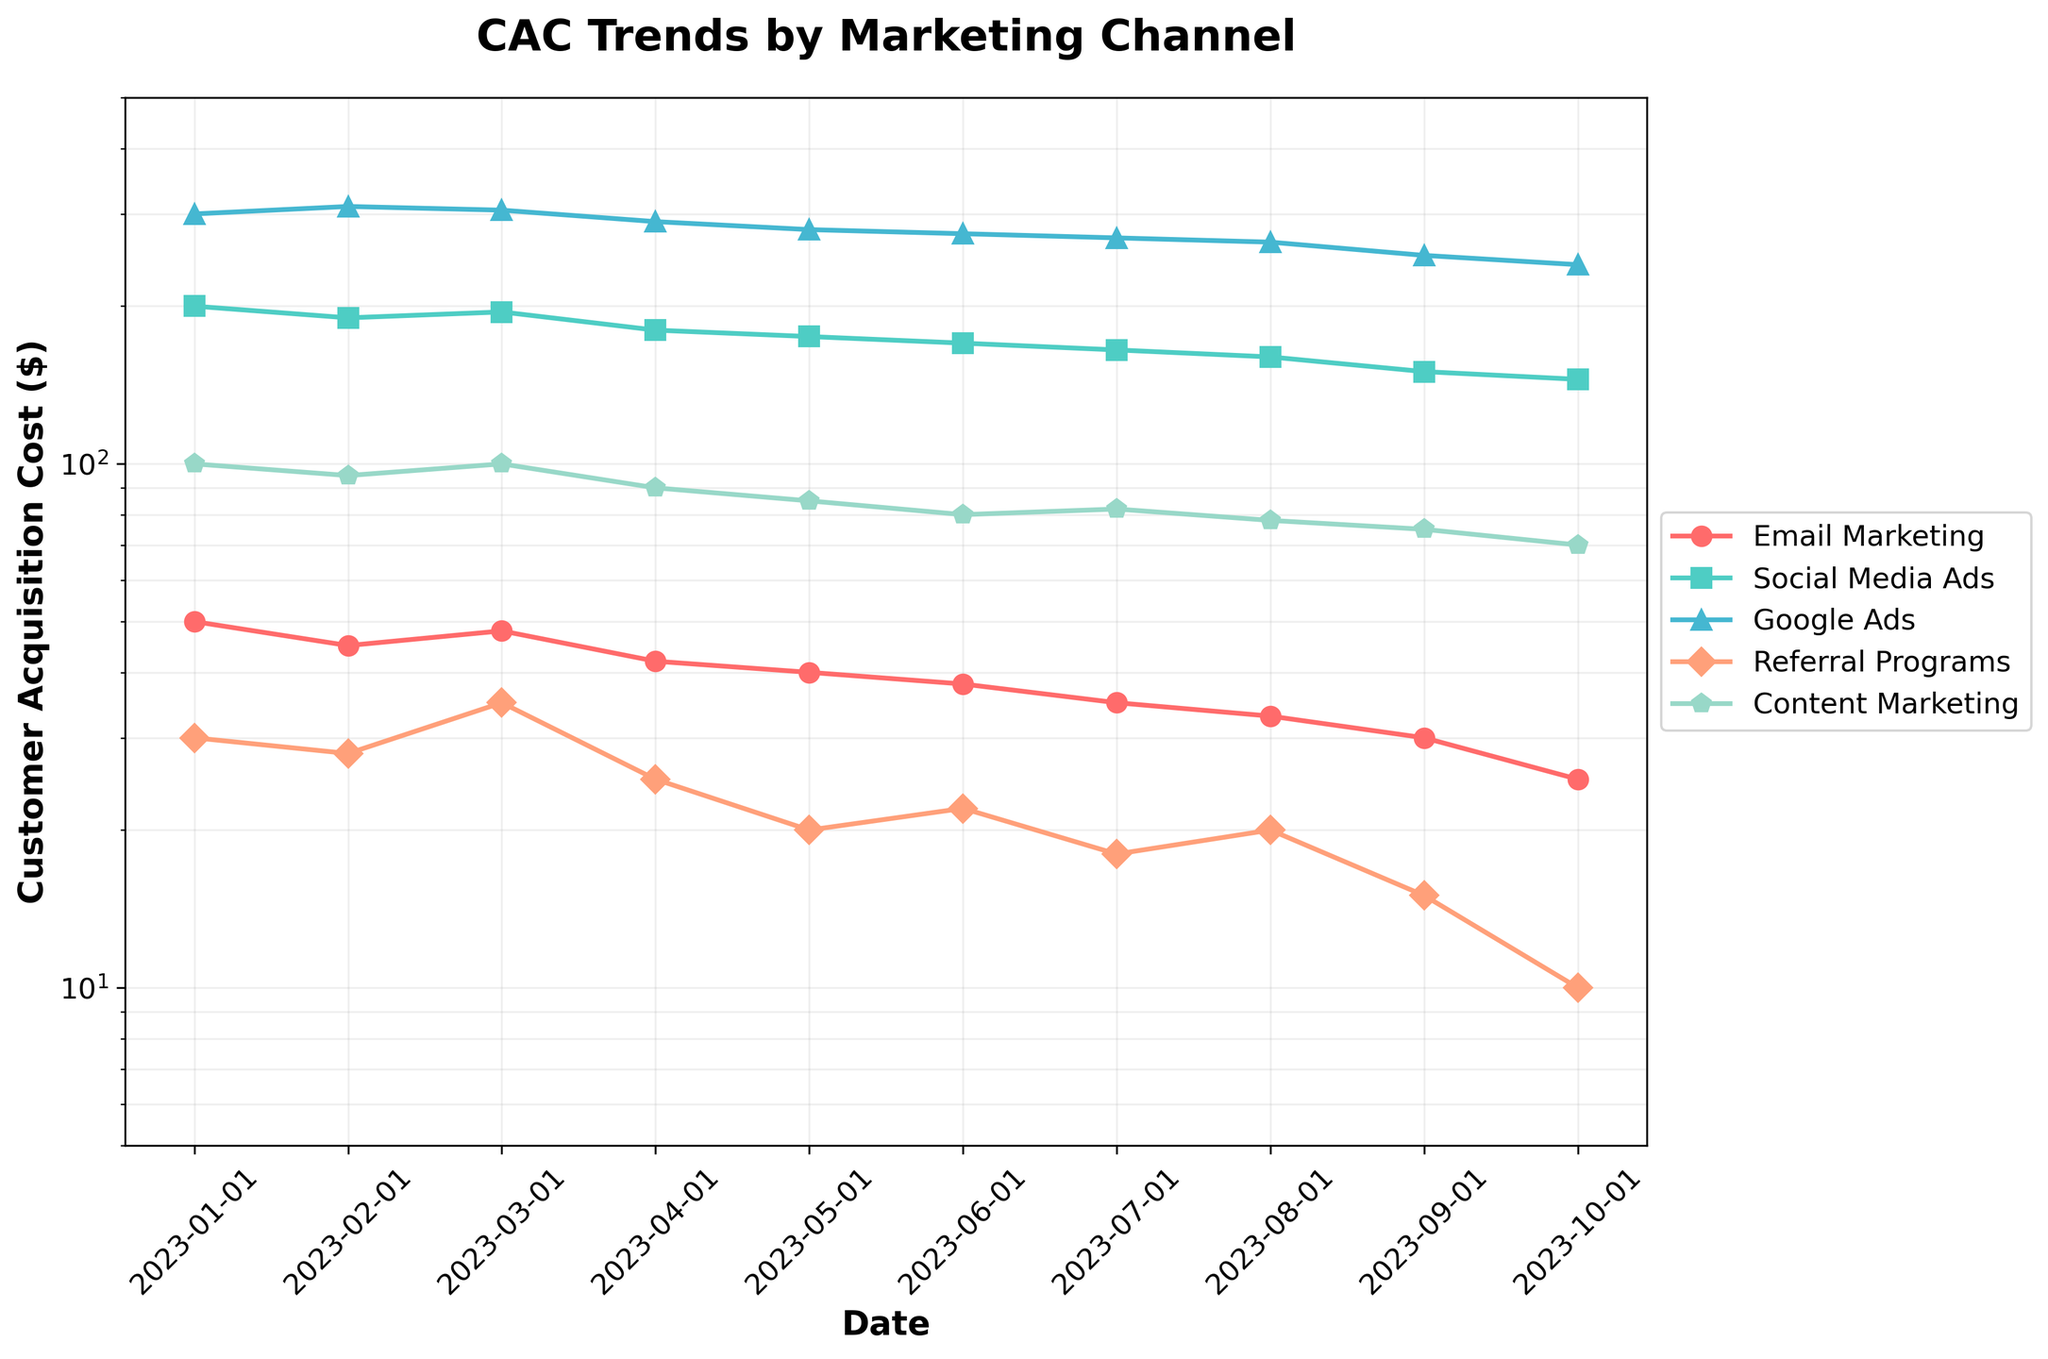What is the title of the plot? The title of the plot is displayed at the top of the figure and usually describes the main purpose or the data visualized. It’s located above the actual plot area, often in larger font size.
Answer: CAC Trends by Marketing Channel What is the range of the y-axis? In log scale plots, the y-axis range is usually indicated by the minimum and maximum value ticks. The y-axis spans from 5 to 500 as described in the code for "ylim".
Answer: 5 to 500 Which marketing channel had the highest Customer Acquisition Cost on January 1st, 2023? By observing the data points on the plotted lines for the given date, the highest y-value corresponds to "Google Ads".
Answer: Google Ads What trend is visible for Referral Programs over the 10 months? By following the data points connected by the line corresponding to Referral Programs, we can observe a generally downward trend in the Customer Acquisition Cost.
Answer: Downward trend What is the most significant difference in CAC between two marketing channels on October 1st, 2023? Examine the figures on October 1st, 2023 for all channels and subtract the lowest CAC (10 for Referral Programs) from the highest (240 for Google Ads).
Answer: 230 If we average the CAC for Content Marketing in the first and last month, what is the result? Identify and sum the CAC for Content Marketing in January (100) and October (70), then divide by 2.
Answer: 85 Which marketing channel showed the most consistent (least variable) CAC trend over the 10 months? Examining the lines, Content Marketing exhibits the least fluctuation in its trend as compared to other channels.
Answer: Content Marketing How did Google Ads CAC change from January to October? The CAC for Google Ads decreases. By noting the data points on January 1st (300) and October 1st (240), we see a reduction.
Answer: Decreased What is the CAC value for Social Media Ads on August 1st, 2023? Locate the plotted data point for Social Media Ads on the figure on August 1st, which corresponds to a CAC of 160.
Answer: 160 On which months did Email Marketing CAC experience a drop compared to the previous month? Observing the Email Marketing line, the drops are on February, April, May, June, July, August, September, and October compared to their previous months respectively. Count each drop.
Answer: 8 times 